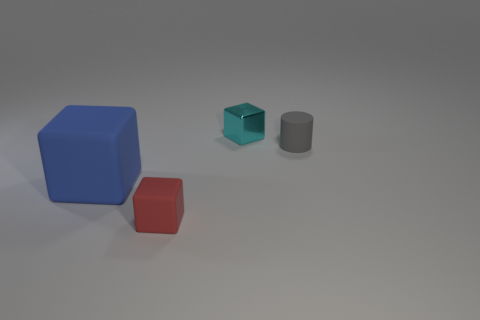Is there a big metallic ball? Based on the image, there is no large metallic ball present. The objects depicted include a blue cube, a smaller teal cube, and a grey cylinder. 